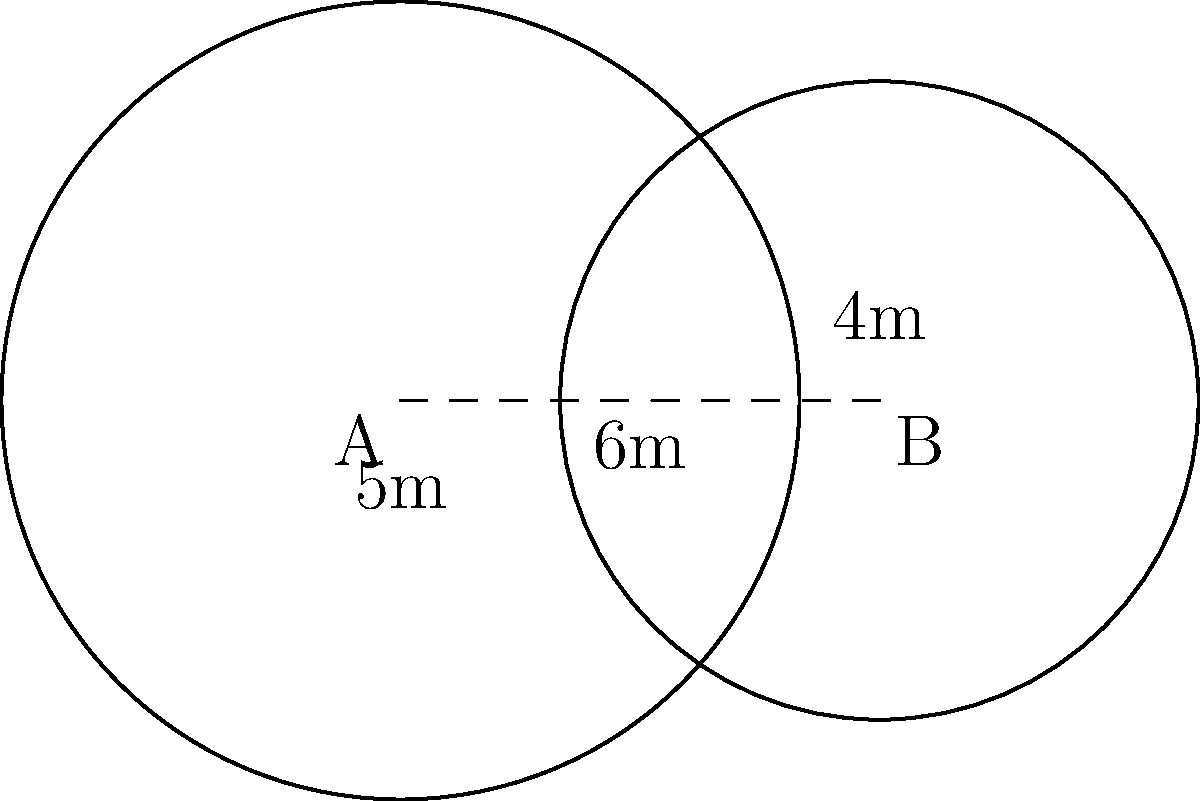In a smart home setup, two Bluetooth beacons are placed 6 meters apart. Beacon A has a range of 5 meters, while Beacon B has a range of 4 meters. What is the area of the region where both Bluetooth signals overlap? To solve this problem, we need to calculate the area of the lens-shaped region formed by the intersection of two circles. We'll use the following steps:

1) First, we need to find the distance from the center of each circle to the points where they intersect. Let's call this distance $x$ for circle A and $y$ for circle B.

2) Using the Pythagorean theorem:
   $x^2 + h^2 = 5^2$ and $y^2 + h^2 = 4^2$, where $h$ is the height of the triangle formed by the centers and an intersection point.

3) We also know that $x + y = 6$ (the distance between the centers).

4) Subtracting the equations in step 2:
   $x^2 - y^2 = 5^2 - 4^2 = 9$

5) Substituting $y = 6 - x$ from step 3:
   $x^2 - (6-x)^2 = 9$
   $x^2 - (36 - 12x + x^2) = 9$
   $12x - 36 = 9$
   $12x = 45$
   $x = 3.75$

6) Therefore, $y = 6 - 3.75 = 2.25$

7) Now we can find $h$ using the Pythagorean theorem:
   $h^2 = 5^2 - 3.75^2 = 25 - 14.0625 = 10.9375$
   $h = \sqrt{10.9375} \approx 3.3072$

8) The area of the lens can be calculated using the formula:
   $A = r_1^2 \arccos(\frac{x}{r_1}) + r_2^2 \arccos(\frac{y}{r_2}) - xy\sqrt{1-(\frac{x^2+y^2-d^2}{2xy})^2}$

   Where $r_1 = 5$, $r_2 = 4$, $x = 3.75$, $y = 2.25$, and $d = 6$

9) Plugging in these values:
   $A = 25 \arccos(\frac{3.75}{5}) + 16 \arccos(\frac{2.25}{4}) - 3.75 * 2.25 * \sqrt{1-(\frac{3.75^2+2.25^2-6^2}{2*3.75*2.25})^2}$

10) Calculating this gives us approximately 10.47 square meters.
Answer: 10.47 square meters 